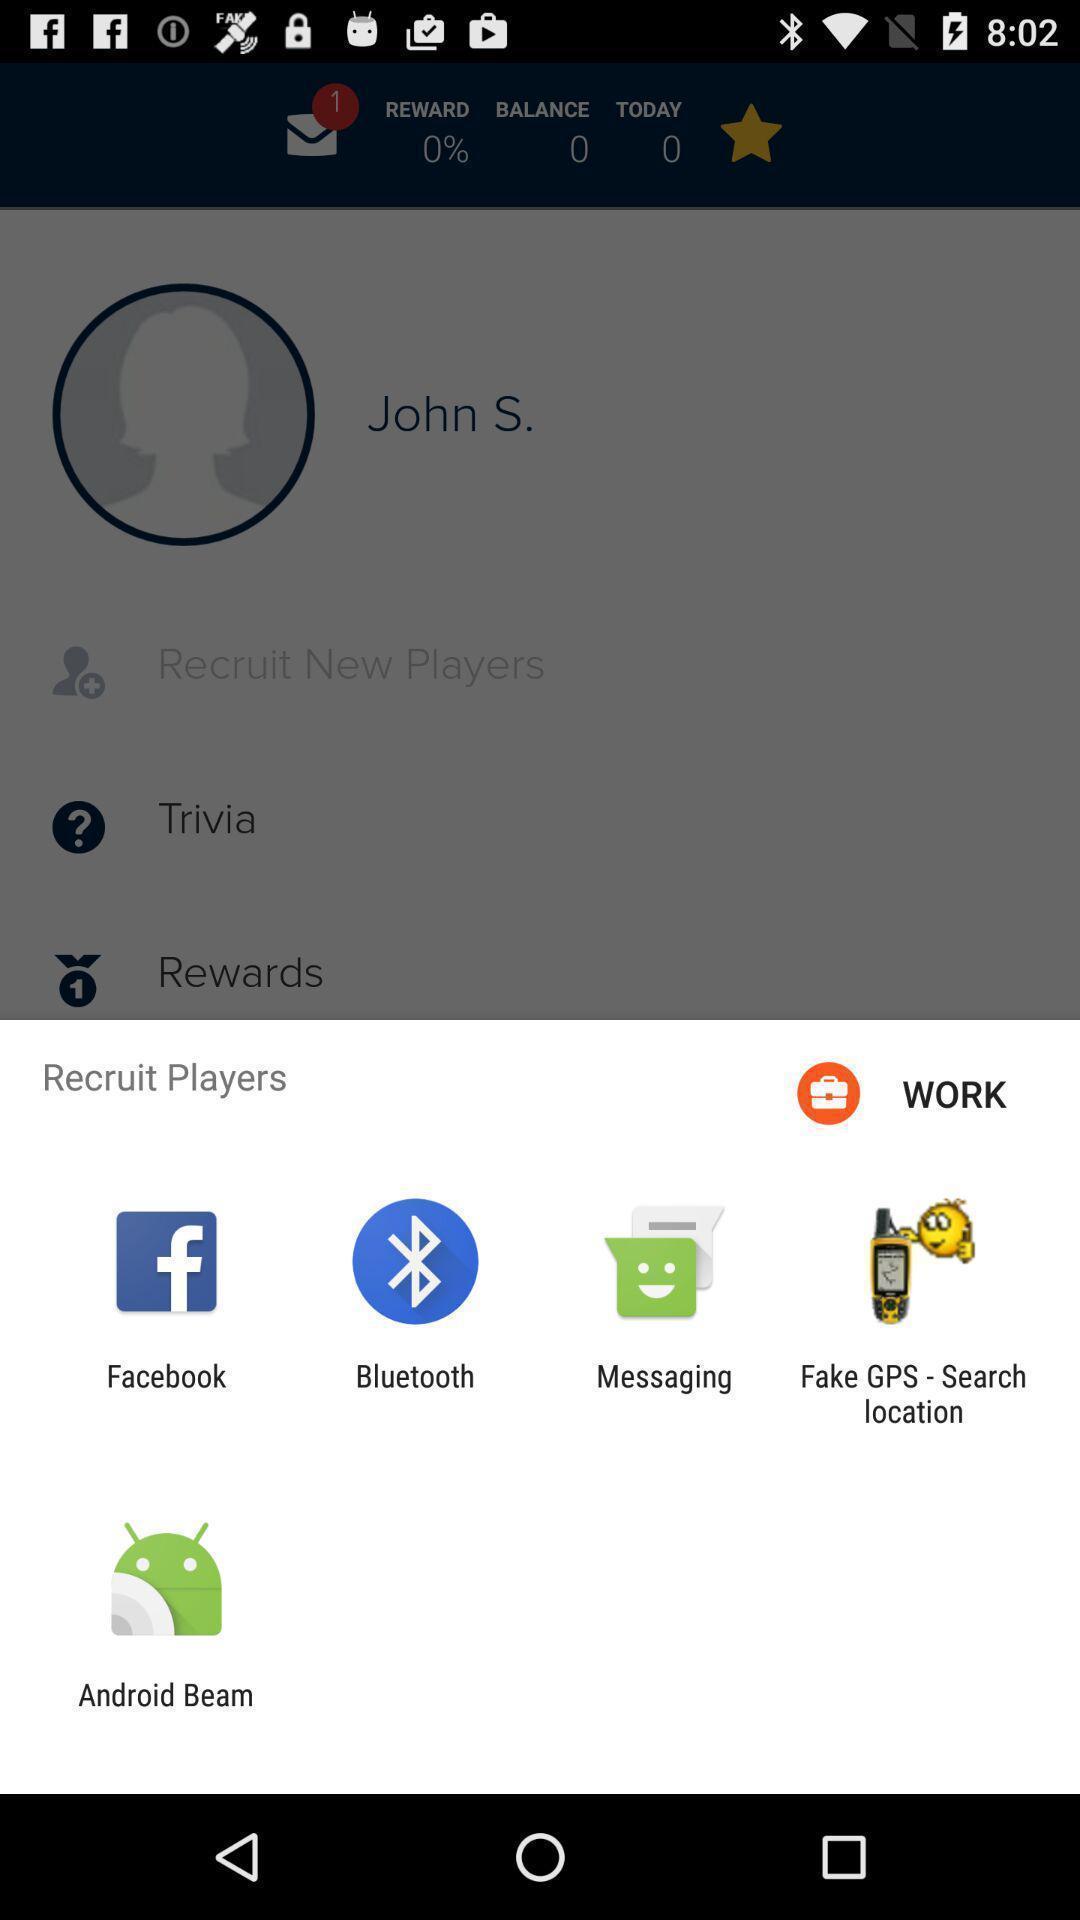Describe the key features of this screenshot. Pop-up showing the different applications. 